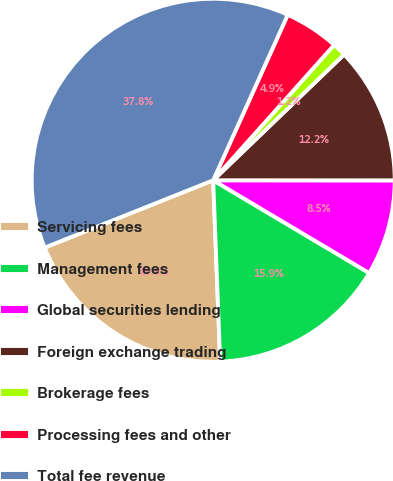<chart> <loc_0><loc_0><loc_500><loc_500><pie_chart><fcel>Servicing fees<fcel>Management fees<fcel>Global securities lending<fcel>Foreign exchange trading<fcel>Brokerage fees<fcel>Processing fees and other<fcel>Total fee revenue<nl><fcel>19.56%<fcel>15.85%<fcel>8.53%<fcel>12.19%<fcel>1.21%<fcel>4.87%<fcel>37.79%<nl></chart> 